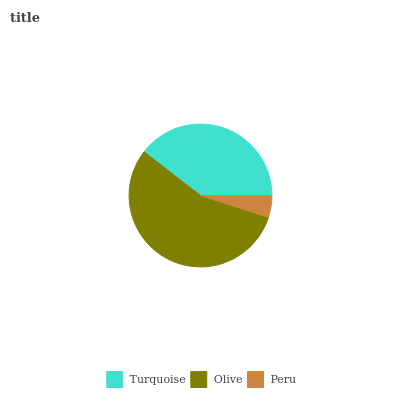Is Peru the minimum?
Answer yes or no. Yes. Is Olive the maximum?
Answer yes or no. Yes. Is Olive the minimum?
Answer yes or no. No. Is Peru the maximum?
Answer yes or no. No. Is Olive greater than Peru?
Answer yes or no. Yes. Is Peru less than Olive?
Answer yes or no. Yes. Is Peru greater than Olive?
Answer yes or no. No. Is Olive less than Peru?
Answer yes or no. No. Is Turquoise the high median?
Answer yes or no. Yes. Is Turquoise the low median?
Answer yes or no. Yes. Is Olive the high median?
Answer yes or no. No. Is Peru the low median?
Answer yes or no. No. 